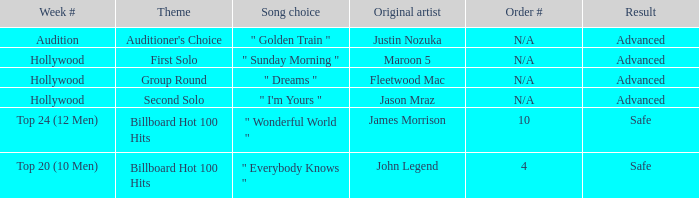What are all the topic wherein music preference is " golden train " Auditioner's Choice. 